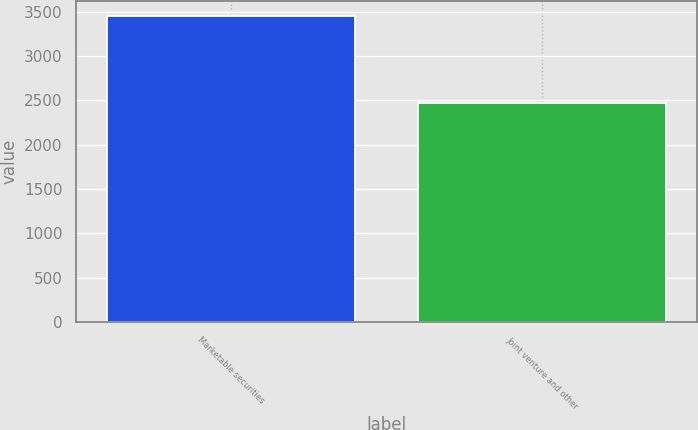Convert chart. <chart><loc_0><loc_0><loc_500><loc_500><bar_chart><fcel>Marketable securities<fcel>Joint venture and other<nl><fcel>3451<fcel>2468<nl></chart> 